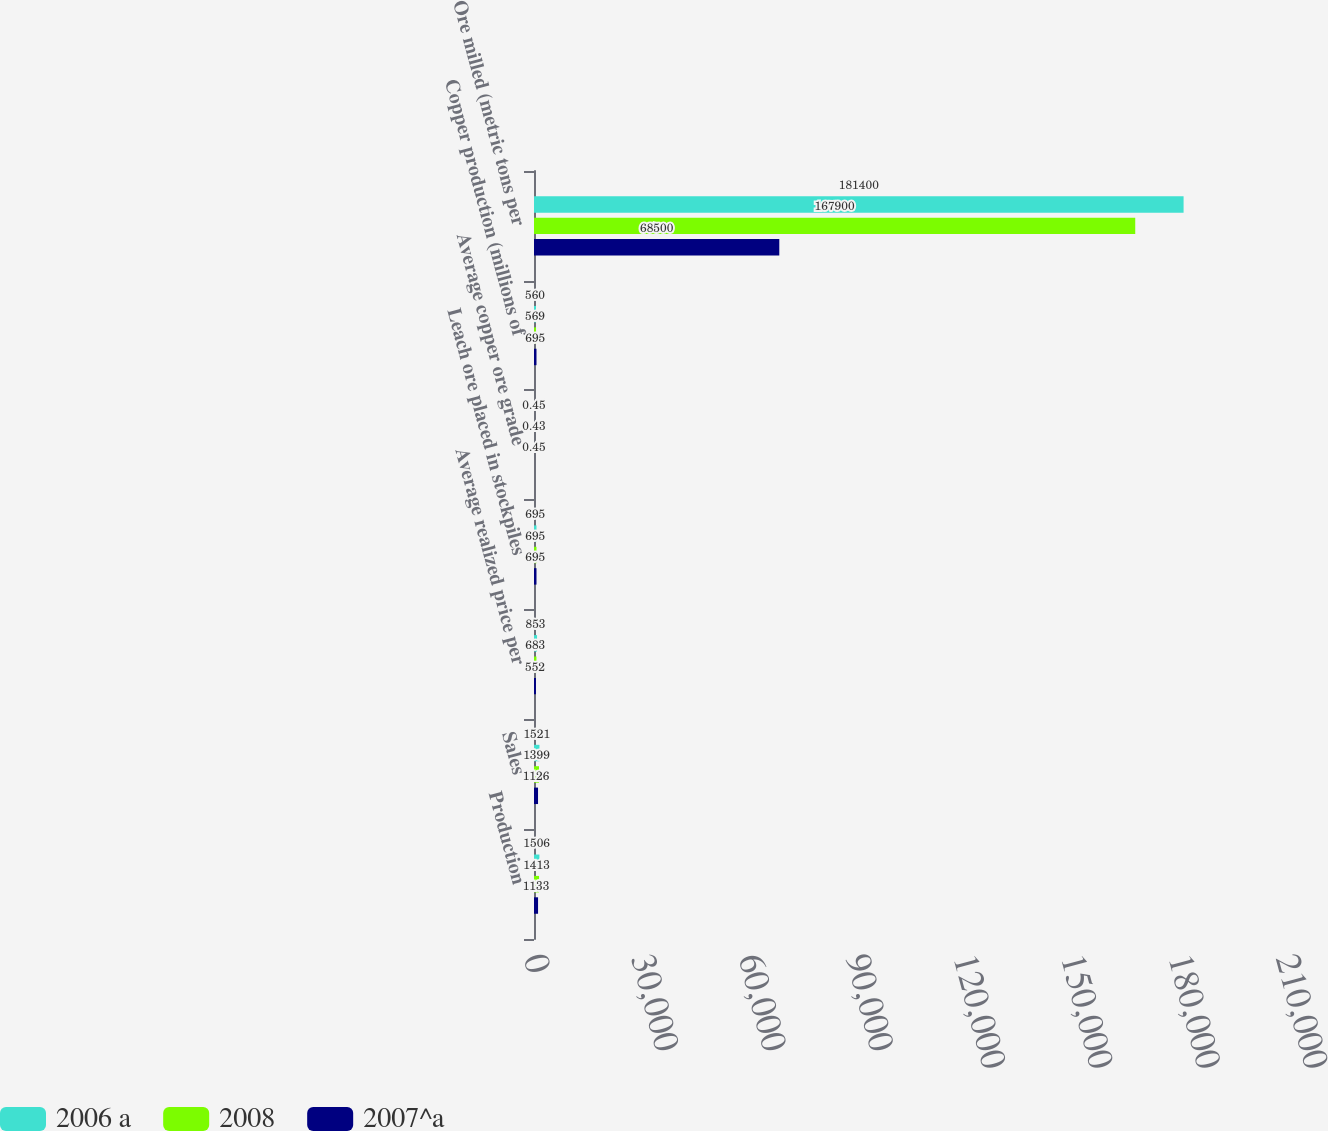Convert chart to OTSL. <chart><loc_0><loc_0><loc_500><loc_500><stacked_bar_chart><ecel><fcel>Production<fcel>Sales<fcel>Average realized price per<fcel>Leach ore placed in stockpiles<fcel>Average copper ore grade<fcel>Copper production (millions of<fcel>Ore milled (metric tons per<nl><fcel>2006 a<fcel>1506<fcel>1521<fcel>853<fcel>695<fcel>0.45<fcel>560<fcel>181400<nl><fcel>2008<fcel>1413<fcel>1399<fcel>683<fcel>695<fcel>0.43<fcel>569<fcel>167900<nl><fcel>2007^a<fcel>1133<fcel>1126<fcel>552<fcel>695<fcel>0.45<fcel>695<fcel>68500<nl></chart> 